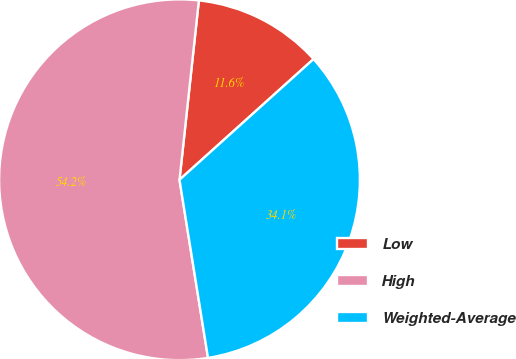Convert chart to OTSL. <chart><loc_0><loc_0><loc_500><loc_500><pie_chart><fcel>Low<fcel>High<fcel>Weighted-Average<nl><fcel>11.62%<fcel>54.24%<fcel>34.14%<nl></chart> 